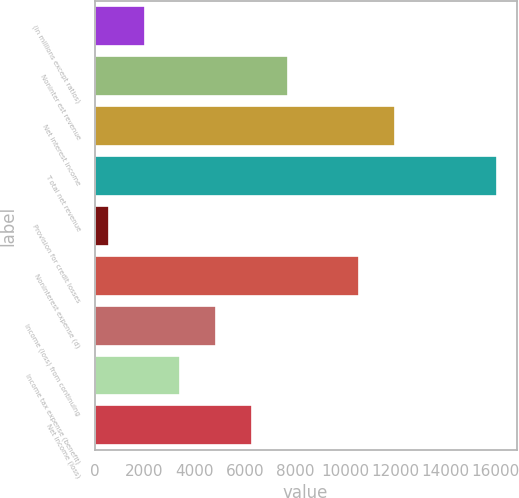Convert chart to OTSL. <chart><loc_0><loc_0><loc_500><loc_500><bar_chart><fcel>(in millions except ratios)<fcel>Noninter est revenue<fcel>Net interest income<fcel>T otal net revenue<fcel>Provision for credit losses<fcel>Noninterest expense (d)<fcel>Income (loss) from continuing<fcel>Income tax expense (benefit)<fcel>Net income (loss)<nl><fcel>2006<fcel>7711.6<fcel>11990.8<fcel>16055.4<fcel>561<fcel>10564.4<fcel>4858.8<fcel>3432.4<fcel>6285.2<nl></chart> 